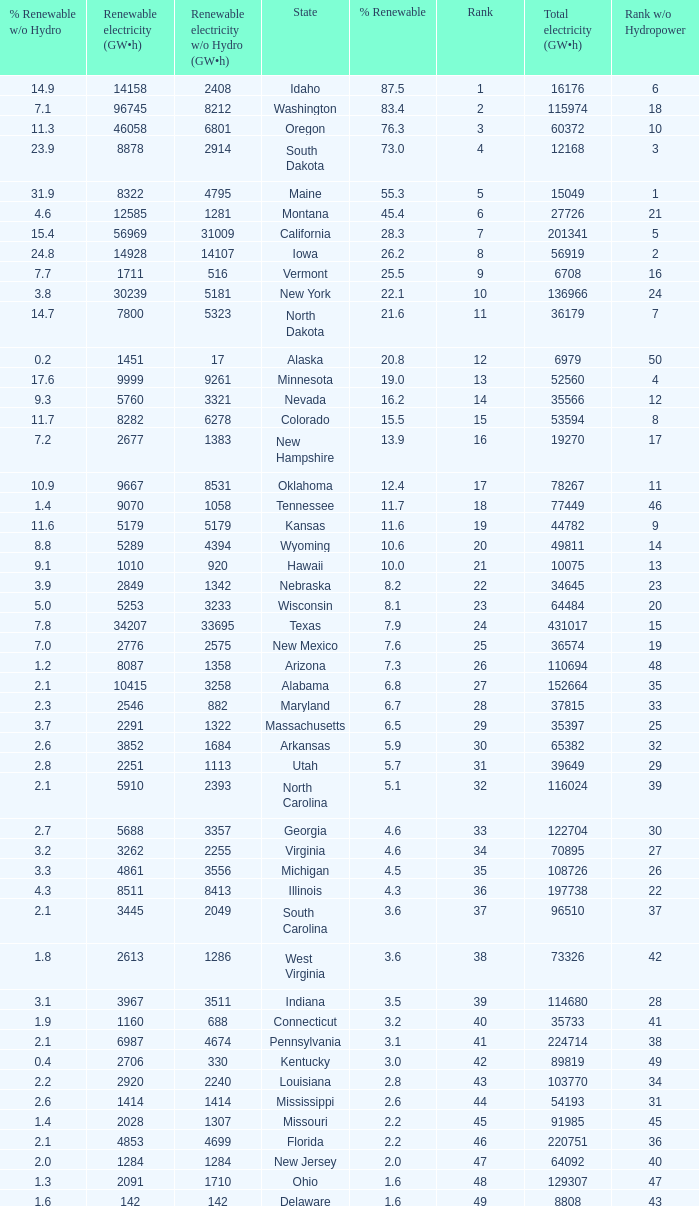What is the amount of renewable electricity without hydrogen power when the percentage of renewable energy is 83.4? 8212.0. 